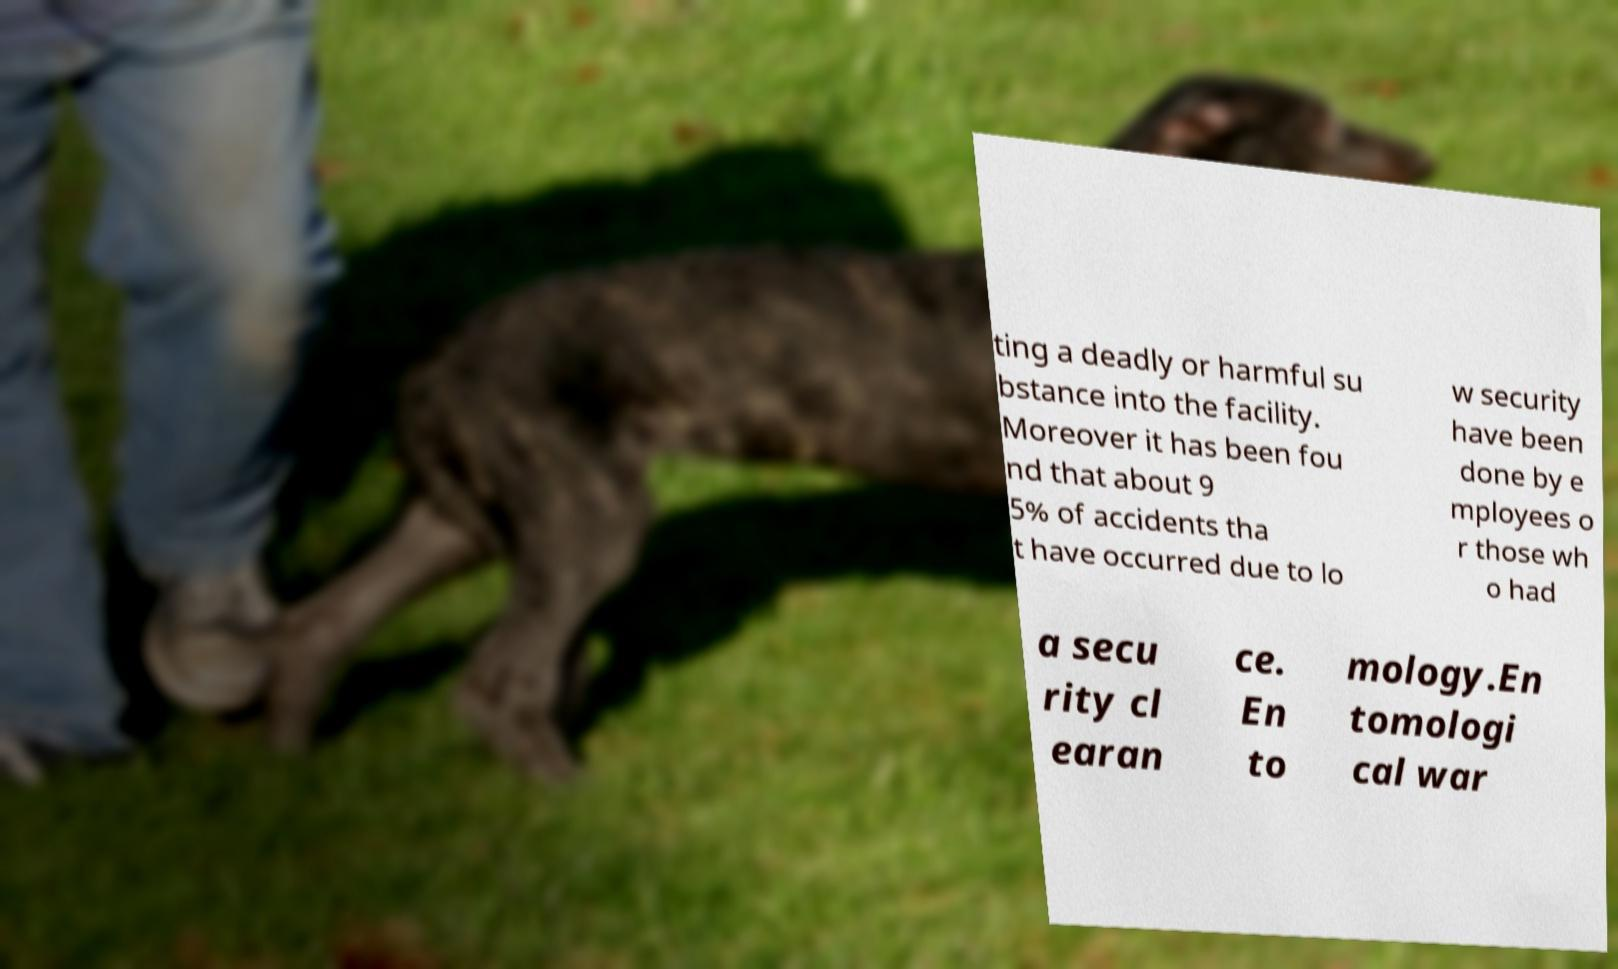What messages or text are displayed in this image? I need them in a readable, typed format. ting a deadly or harmful su bstance into the facility. Moreover it has been fou nd that about 9 5% of accidents tha t have occurred due to lo w security have been done by e mployees o r those wh o had a secu rity cl earan ce. En to mology.En tomologi cal war 